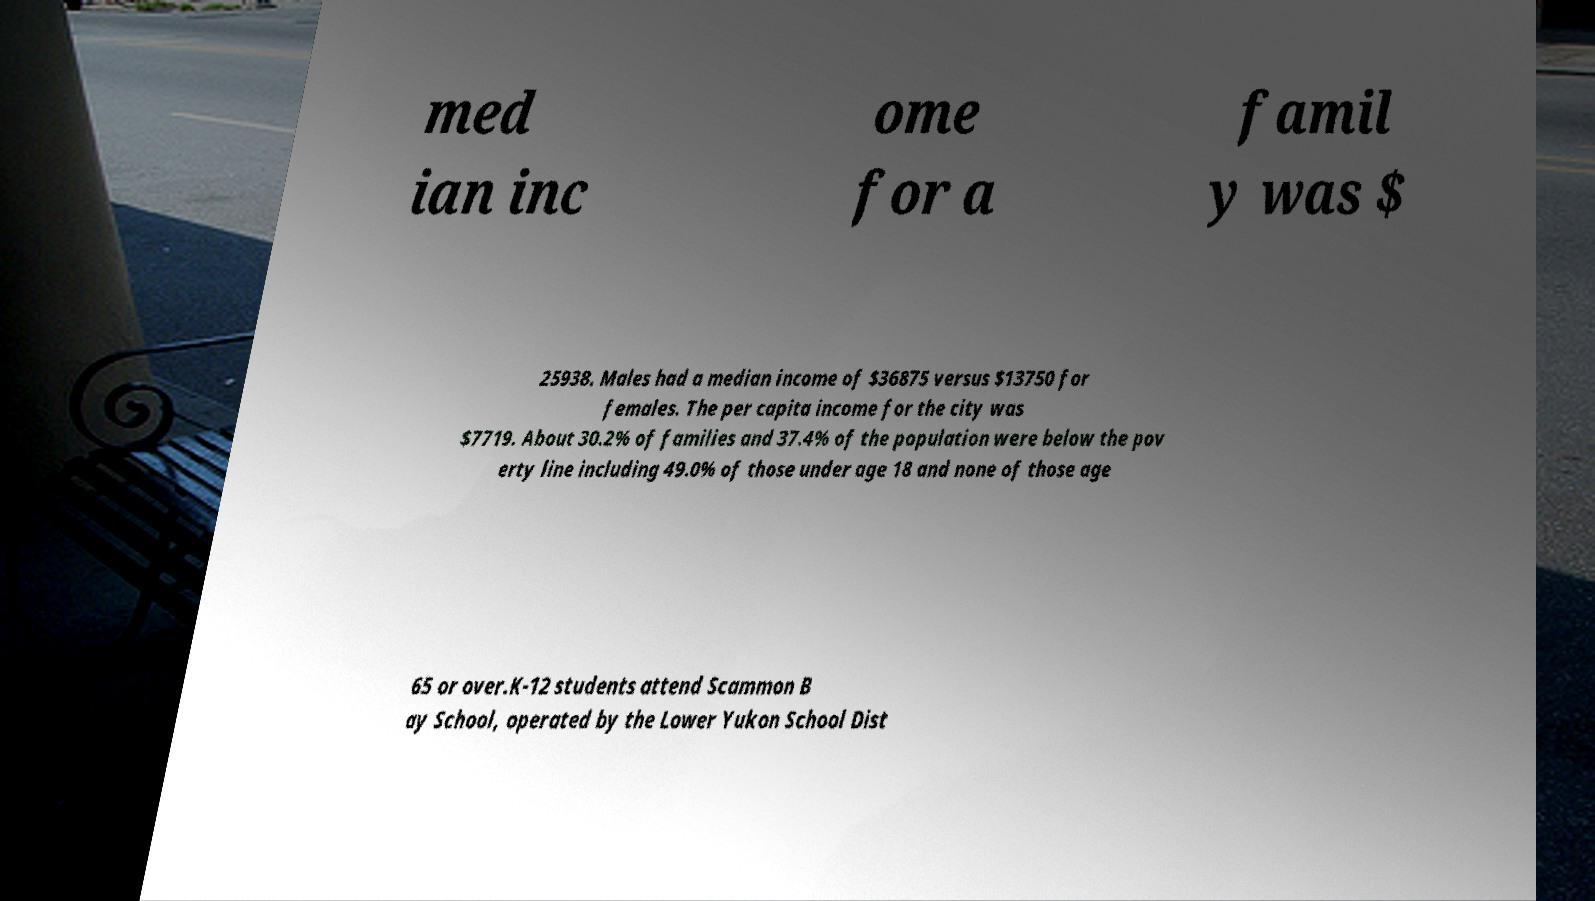Can you read and provide the text displayed in the image?This photo seems to have some interesting text. Can you extract and type it out for me? med ian inc ome for a famil y was $ 25938. Males had a median income of $36875 versus $13750 for females. The per capita income for the city was $7719. About 30.2% of families and 37.4% of the population were below the pov erty line including 49.0% of those under age 18 and none of those age 65 or over.K-12 students attend Scammon B ay School, operated by the Lower Yukon School Dist 